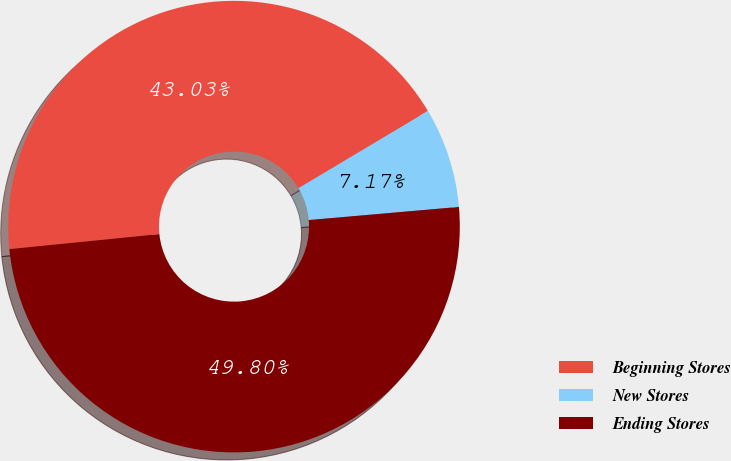Convert chart to OTSL. <chart><loc_0><loc_0><loc_500><loc_500><pie_chart><fcel>Beginning Stores<fcel>New Stores<fcel>Ending Stores<nl><fcel>43.03%<fcel>7.17%<fcel>49.8%<nl></chart> 